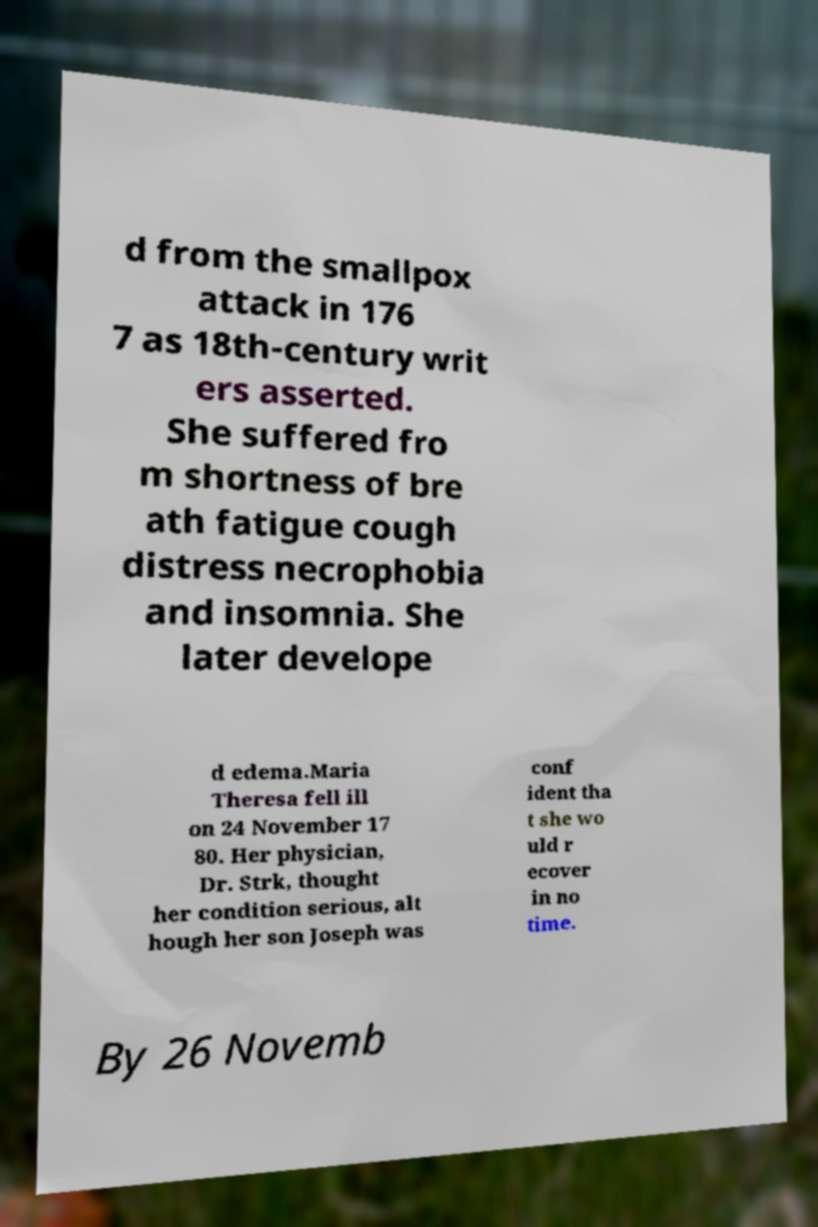Could you assist in decoding the text presented in this image and type it out clearly? d from the smallpox attack in 176 7 as 18th-century writ ers asserted. She suffered fro m shortness of bre ath fatigue cough distress necrophobia and insomnia. She later develope d edema.Maria Theresa fell ill on 24 November 17 80. Her physician, Dr. Strk, thought her condition serious, alt hough her son Joseph was conf ident tha t she wo uld r ecover in no time. By 26 Novemb 